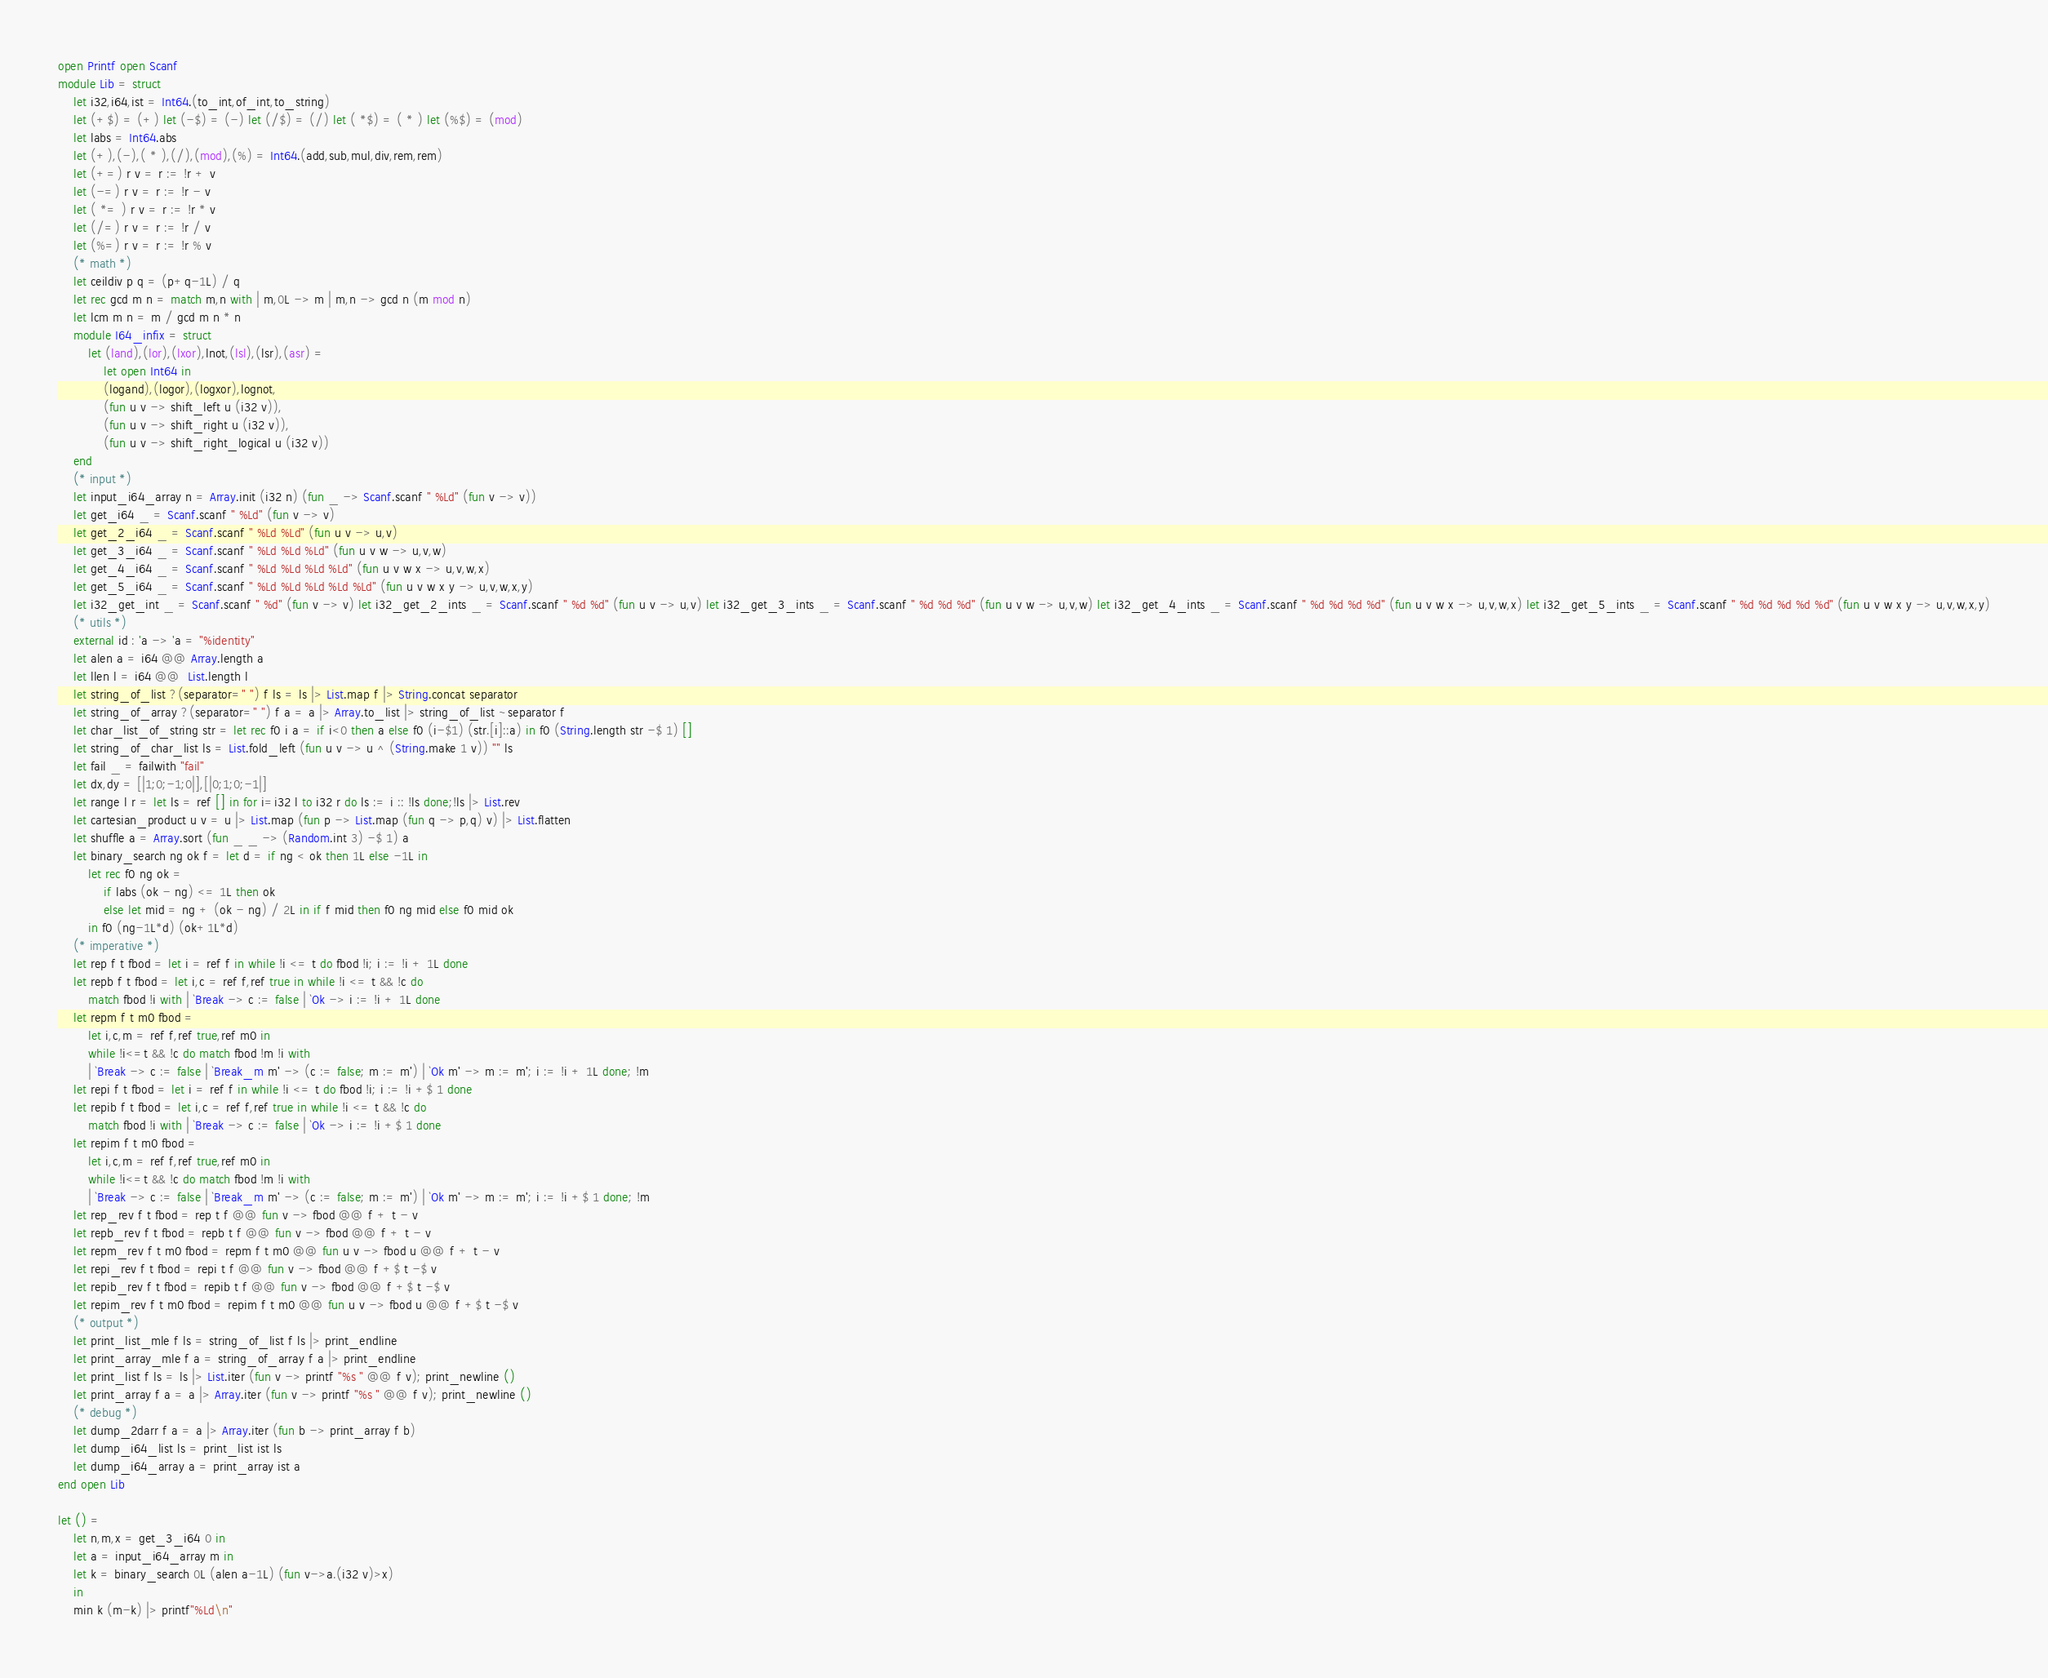Convert code to text. <code><loc_0><loc_0><loc_500><loc_500><_OCaml_>open Printf open Scanf
module Lib = struct
	let i32,i64,ist = Int64.(to_int,of_int,to_string)
	let (+$) = (+) let (-$) = (-) let (/$) = (/) let ( *$) = ( * ) let (%$) = (mod)
	let labs = Int64.abs
	let (+),(-),( * ),(/),(mod),(%) = Int64.(add,sub,mul,div,rem,rem)
	let (+=) r v = r := !r + v
	let (-=) r v = r := !r - v
	let ( *= ) r v = r := !r * v
	let (/=) r v = r := !r / v
	let (%=) r v = r := !r % v
	(* math *)
	let ceildiv p q = (p+q-1L) / q
	let rec gcd m n = match m,n with | m,0L -> m | m,n -> gcd n (m mod n)
	let lcm m n = m / gcd m n * n 
	module I64_infix = struct
		let (land),(lor),(lxor),lnot,(lsl),(lsr),(asr) =
			let open Int64 in
			(logand),(logor),(logxor),lognot,
			(fun u v -> shift_left u (i32 v)),
			(fun u v -> shift_right u (i32 v)),
			(fun u v -> shift_right_logical u (i32 v))
	end
	(* input *)
	let input_i64_array n = Array.init (i32 n) (fun _ -> Scanf.scanf " %Ld" (fun v -> v))
	let get_i64 _ = Scanf.scanf " %Ld" (fun v -> v)
	let get_2_i64 _ = Scanf.scanf " %Ld %Ld" (fun u v -> u,v)
	let get_3_i64 _ = Scanf.scanf " %Ld %Ld %Ld" (fun u v w -> u,v,w)
	let get_4_i64 _ = Scanf.scanf " %Ld %Ld %Ld %Ld" (fun u v w x -> u,v,w,x)
	let get_5_i64 _ = Scanf.scanf " %Ld %Ld %Ld %Ld %Ld" (fun u v w x y -> u,v,w,x,y)
	let i32_get_int _ = Scanf.scanf " %d" (fun v -> v) let i32_get_2_ints _ = Scanf.scanf " %d %d" (fun u v -> u,v) let i32_get_3_ints _ = Scanf.scanf " %d %d %d" (fun u v w -> u,v,w) let i32_get_4_ints _ = Scanf.scanf " %d %d %d %d" (fun u v w x -> u,v,w,x) let i32_get_5_ints _ = Scanf.scanf " %d %d %d %d %d" (fun u v w x y -> u,v,w,x,y)
	(* utils *)
	external id : 'a -> 'a = "%identity"
	let alen a = i64 @@ Array.length a
	let llen l = i64 @@  List.length l
	let string_of_list ?(separator=" ") f ls = ls |> List.map f |> String.concat separator
	let string_of_array ?(separator=" ") f a = a |> Array.to_list |> string_of_list ~separator f
	let char_list_of_string str = let rec f0 i a = if i<0 then a else f0 (i-$1) (str.[i]::a) in f0 (String.length str -$ 1) []
	let string_of_char_list ls = List.fold_left (fun u v -> u ^ (String.make 1 v)) "" ls
	let fail _ = failwith "fail"
	let dx,dy = [|1;0;-1;0|],[|0;1;0;-1|]
	let range l r = let ls = ref [] in for i=i32 l to i32 r do ls := i :: !ls done;!ls |> List.rev
	let cartesian_product u v = u |> List.map (fun p -> List.map (fun q -> p,q) v) |> List.flatten
	let shuffle a = Array.sort (fun _ _ -> (Random.int 3) -$ 1) a
	let binary_search ng ok f = let d = if ng < ok then 1L else -1L in
		let rec f0 ng ok =
			if labs (ok - ng) <= 1L then ok
			else let mid = ng + (ok - ng) / 2L in if f mid then f0 ng mid else f0 mid ok
		in f0 (ng-1L*d) (ok+1L*d)
	(* imperative *)
	let rep f t fbod = let i = ref f in while !i <= t do fbod !i; i := !i + 1L done
	let repb f t fbod = let i,c = ref f,ref true in while !i <= t && !c do
		match fbod !i with | `Break -> c := false | `Ok -> i := !i + 1L done
	let repm f t m0 fbod =
		let i,c,m = ref f,ref true,ref m0 in
		while !i<=t && !c do match fbod !m !i with
		| `Break -> c := false | `Break_m m' -> (c := false; m := m') | `Ok m' -> m := m'; i := !i + 1L done; !m
	let repi f t fbod = let i = ref f in while !i <= t do fbod !i; i := !i +$ 1 done
	let repib f t fbod = let i,c = ref f,ref true in while !i <= t && !c do
		match fbod !i with | `Break -> c := false | `Ok -> i := !i +$ 1 done
	let repim f t m0 fbod =
		let i,c,m = ref f,ref true,ref m0 in
		while !i<=t && !c do match fbod !m !i with
		| `Break -> c := false | `Break_m m' -> (c := false; m := m') | `Ok m' -> m := m'; i := !i +$ 1 done; !m
	let rep_rev f t fbod = rep t f @@ fun v -> fbod @@ f + t - v
	let repb_rev f t fbod = repb t f @@ fun v -> fbod @@ f + t - v
	let repm_rev f t m0 fbod = repm f t m0 @@ fun u v -> fbod u @@ f + t - v
	let repi_rev f t fbod = repi t f @@ fun v -> fbod @@ f +$ t -$ v
	let repib_rev f t fbod = repib t f @@ fun v -> fbod @@ f +$ t -$ v
	let repim_rev f t m0 fbod = repim f t m0 @@ fun u v -> fbod u @@ f +$ t -$ v
	(* output *)
	let print_list_mle f ls = string_of_list f ls |> print_endline
	let print_array_mle f a = string_of_array f a |> print_endline
	let print_list f ls = ls |> List.iter (fun v -> printf "%s " @@ f v); print_newline ()
	let print_array f a = a |> Array.iter (fun v -> printf "%s " @@ f v); print_newline ()
	(* debug *)
	let dump_2darr f a = a |> Array.iter (fun b -> print_array f b)
	let dump_i64_list ls = print_list ist ls
	let dump_i64_array a = print_array ist a
end open Lib

let () =
	let n,m,x = get_3_i64 0 in
	let a = input_i64_array m in
	let k = binary_search 0L (alen a-1L) (fun v->a.(i32 v)>x) 
	in
	min k (m-k) |> printf"%Ld\n"

</code> 